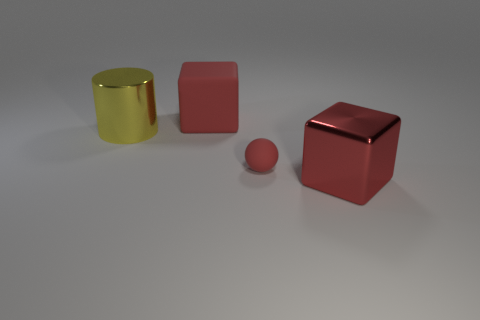Subtract all cylinders. How many objects are left? 3 Add 1 large matte things. How many objects exist? 5 Add 4 small matte balls. How many small matte balls exist? 5 Subtract 0 brown cubes. How many objects are left? 4 Subtract 1 cylinders. How many cylinders are left? 0 Subtract all purple cylinders. Subtract all brown spheres. How many cylinders are left? 1 Subtract all purple spheres. How many purple cubes are left? 0 Subtract all red shiny objects. Subtract all small yellow cylinders. How many objects are left? 3 Add 4 red balls. How many red balls are left? 5 